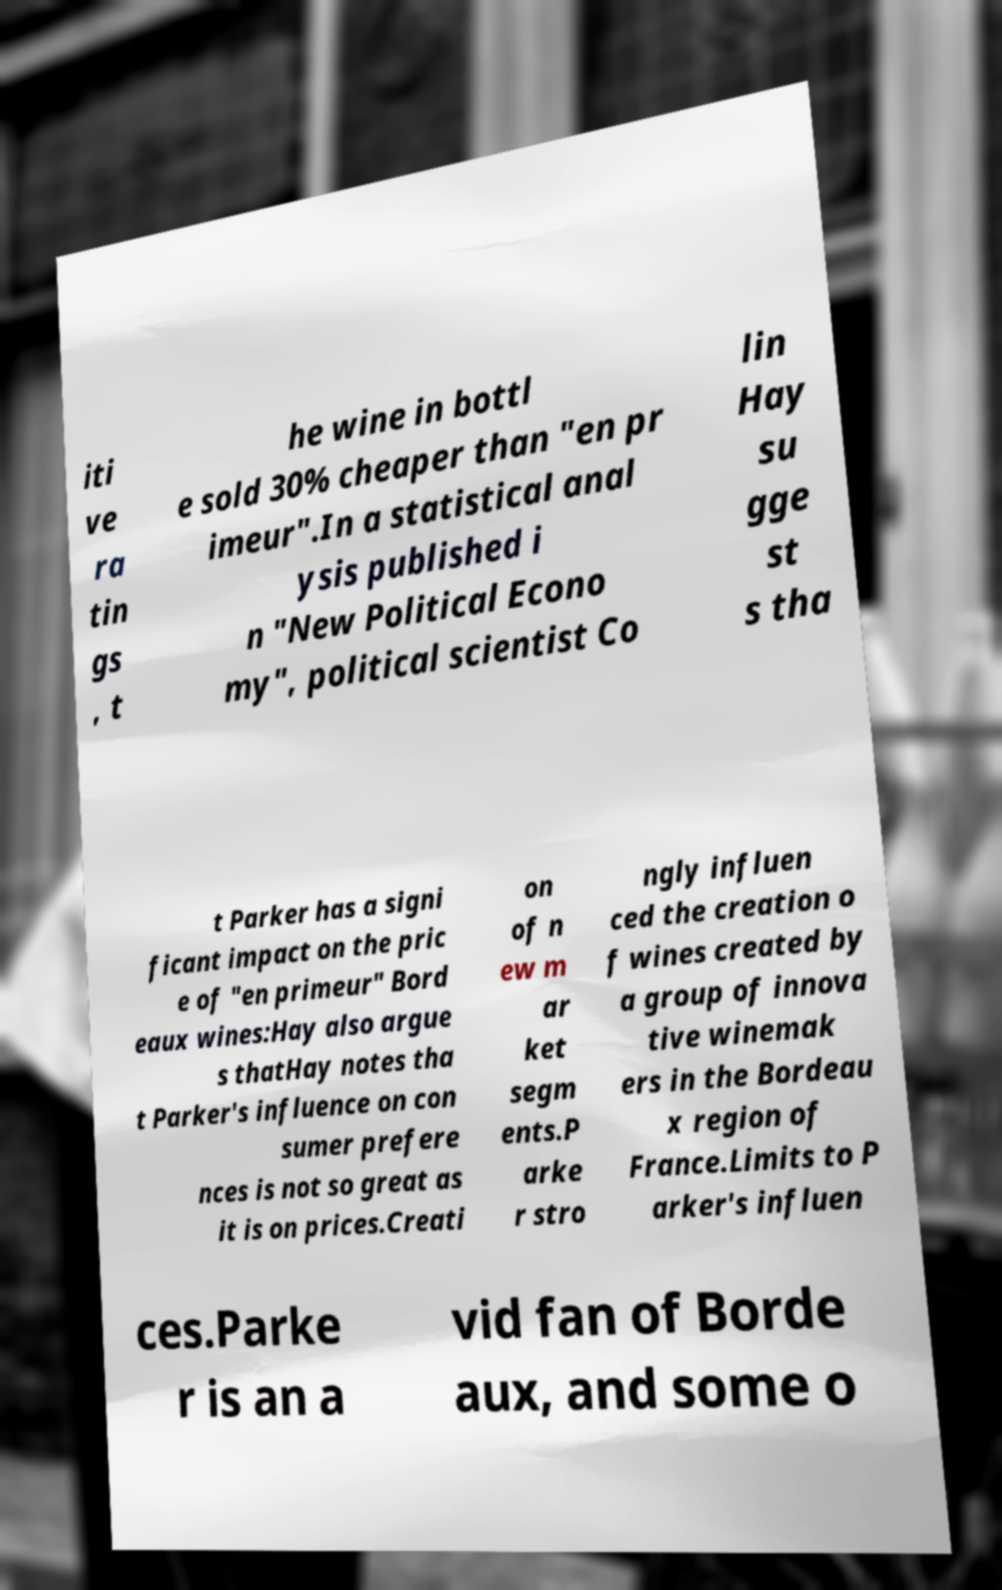Please read and relay the text visible in this image. What does it say? iti ve ra tin gs , t he wine in bottl e sold 30% cheaper than "en pr imeur".In a statistical anal ysis published i n "New Political Econo my", political scientist Co lin Hay su gge st s tha t Parker has a signi ficant impact on the pric e of "en primeur" Bord eaux wines:Hay also argue s thatHay notes tha t Parker's influence on con sumer prefere nces is not so great as it is on prices.Creati on of n ew m ar ket segm ents.P arke r stro ngly influen ced the creation o f wines created by a group of innova tive winemak ers in the Bordeau x region of France.Limits to P arker's influen ces.Parke r is an a vid fan of Borde aux, and some o 